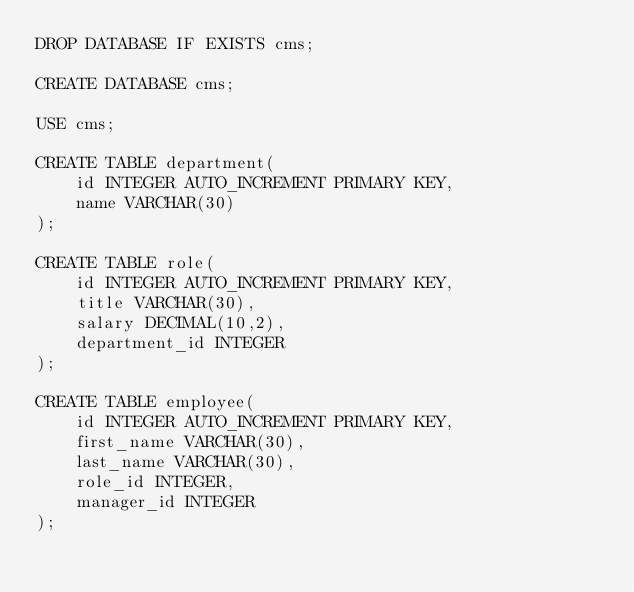Convert code to text. <code><loc_0><loc_0><loc_500><loc_500><_SQL_>DROP DATABASE IF EXISTS cms;

CREATE DATABASE cms;

USE cms;

CREATE TABLE department(
	id INTEGER AUTO_INCREMENT PRIMARY KEY,
    name VARCHAR(30)
);

CREATE TABLE role(
	id INTEGER AUTO_INCREMENT PRIMARY KEY,
    title VARCHAR(30),
    salary DECIMAL(10,2),
    department_id INTEGER
);

CREATE TABLE employee(
	id INTEGER AUTO_INCREMENT PRIMARY KEY,
    first_name VARCHAR(30),
    last_name VARCHAR(30),
    role_id INTEGER,
    manager_id INTEGER
);</code> 